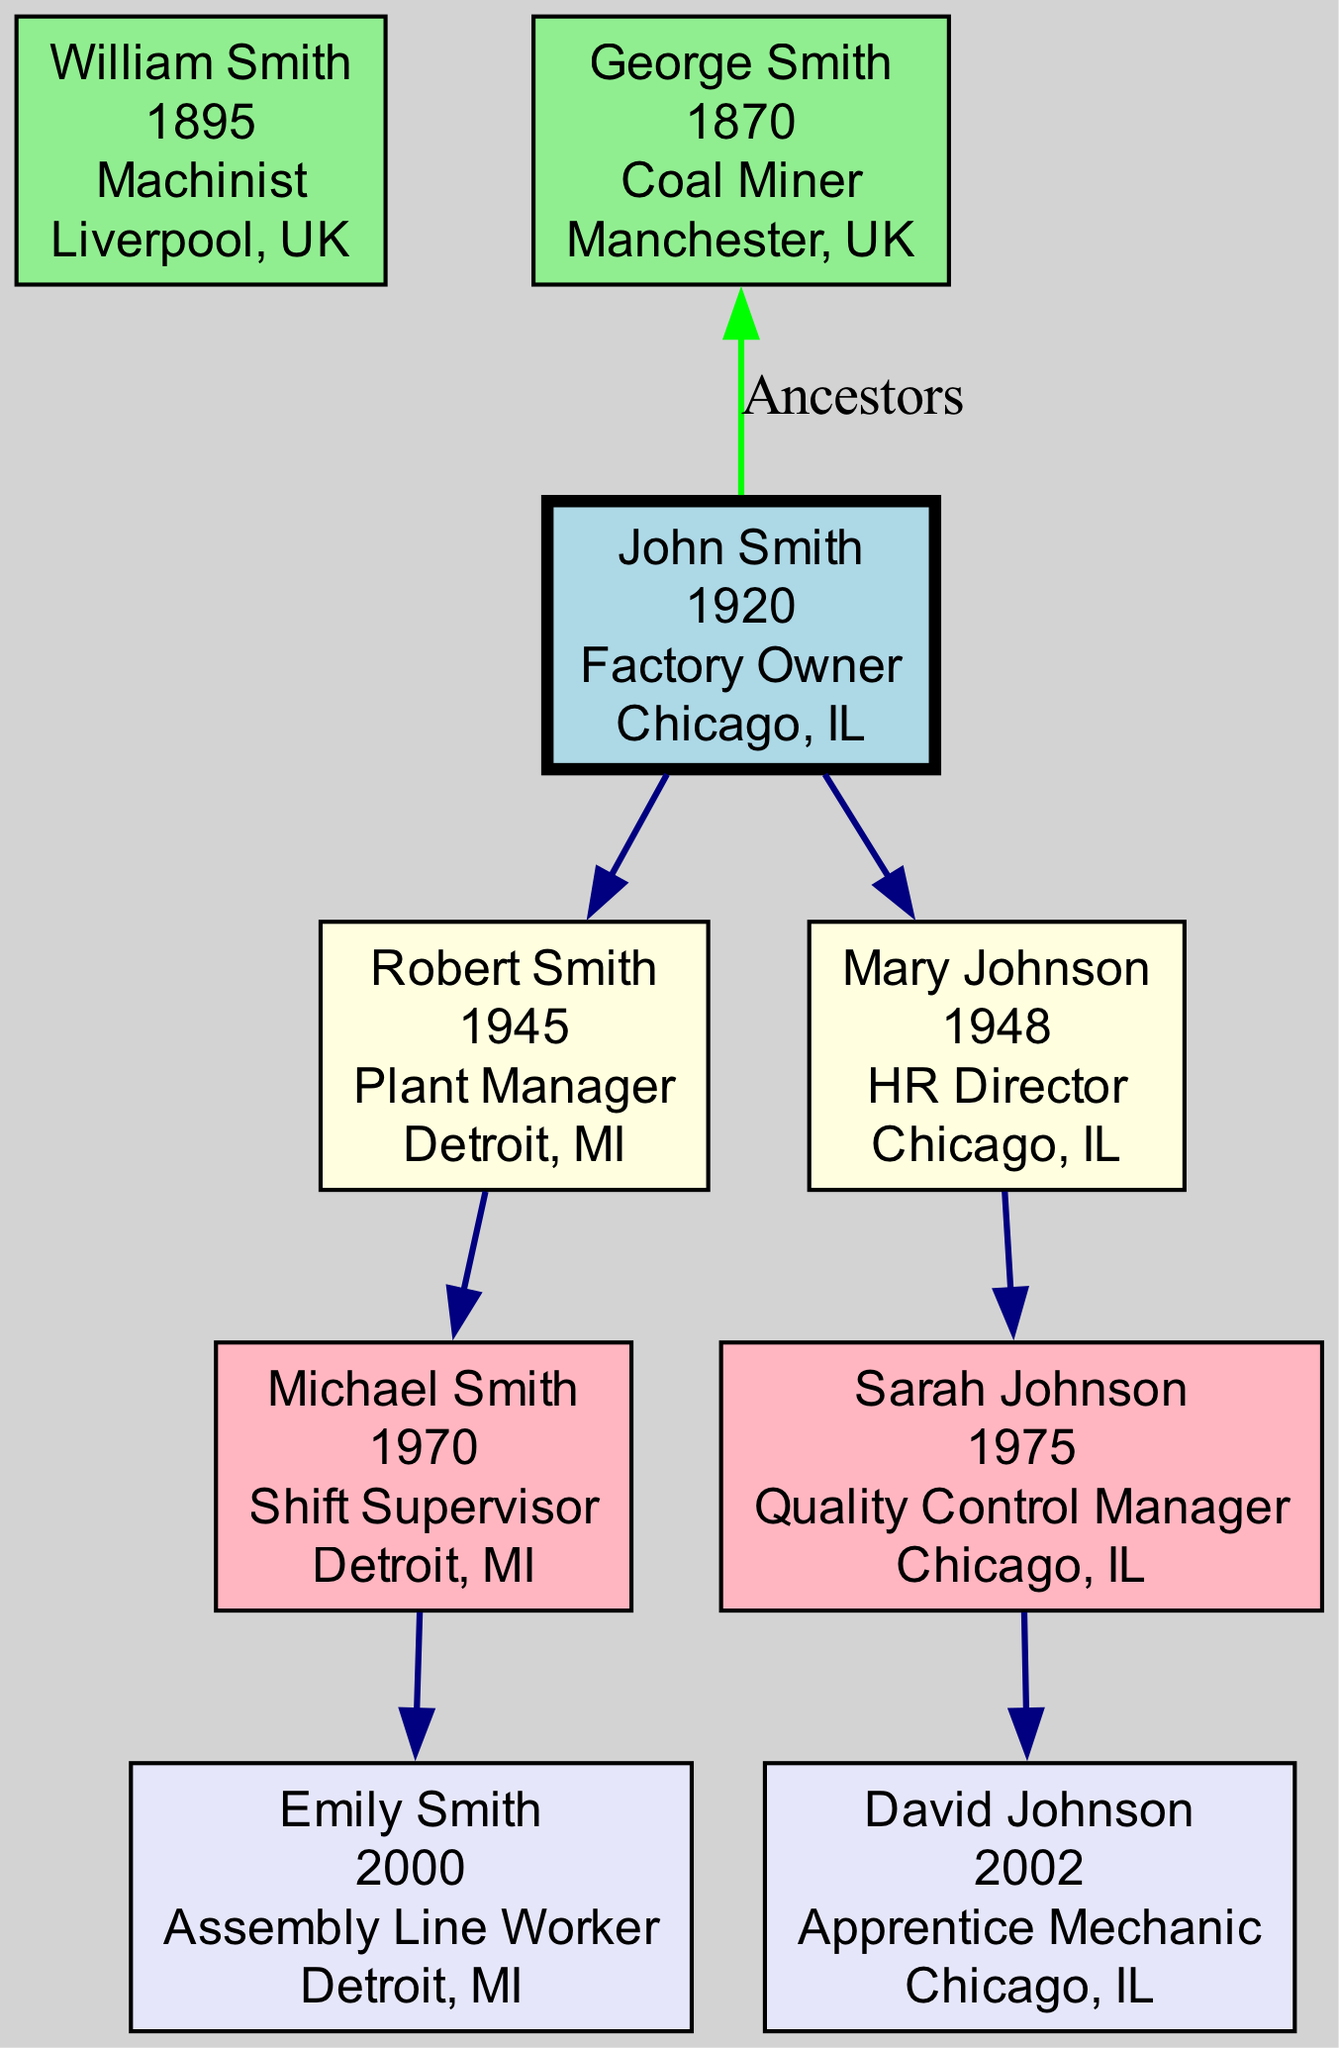What is the name of the factory owner? The factory owner is the root of the family tree, which indicates that their primary occupation is shown at the top. The name mentioned in the root node is John Smith.
Answer: John Smith How many children does John Smith have? The diagram clearly shows there are two nodes directly branching from John Smith, indicating he has two children.
Answer: 2 What is the occupation of Robert Smith? Robert Smith is a child of John Smith, and his occupation is listed next to his node in the tree, which states he is a Plant Manager.
Answer: Plant Manager Who is the HR Director? The HR Director is one of the children of John Smith, and specifically, this title is associated with Mary Johnson according to the information in her node.
Answer: Mary Johnson Which grandchild is located in Chicago, IL? By examining the grandchildren nodes, it becomes evident that Sarah Johnson’s location is listed as Chicago, IL, whereas the other grandchild, Michael Smith, is in Detroit, MI.
Answer: Sarah Johnson What was the occupation of George Smith? George Smith is included among the ancestors and his occupation is stated in the ancestor section of the diagram, which says he was a Coal Miner.
Answer: Coal Miner Which generation does Emily Smith belong to? Emily Smith is listed among the great-grandchildren of John Smith. Reading the family tree from John Smith down to Emily Smith indicates that she is part of the fourth generation, following the sequence of roots, children, grandchildren, and then great-grandchildren.
Answer: Great-Grandchild How is Sarah Johnson related to John Smith? Sarah Johnson is the child of Mary Johnson, who is a direct descendant of John Smith. This can be determined by tracing the branches down the family tree from John Smith through Mary Johnson to Sarah Johnson.
Answer: Grandchild How many ancestors are listed in the diagram? The ancestors section of the diagram mentions William Smith and George Smith, indicating that there are two entries in this category.
Answer: 2 